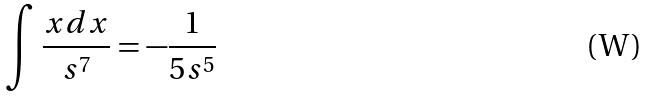<formula> <loc_0><loc_0><loc_500><loc_500>\int \frac { x d x } { s ^ { 7 } } = - \frac { 1 } { 5 s ^ { 5 } }</formula> 